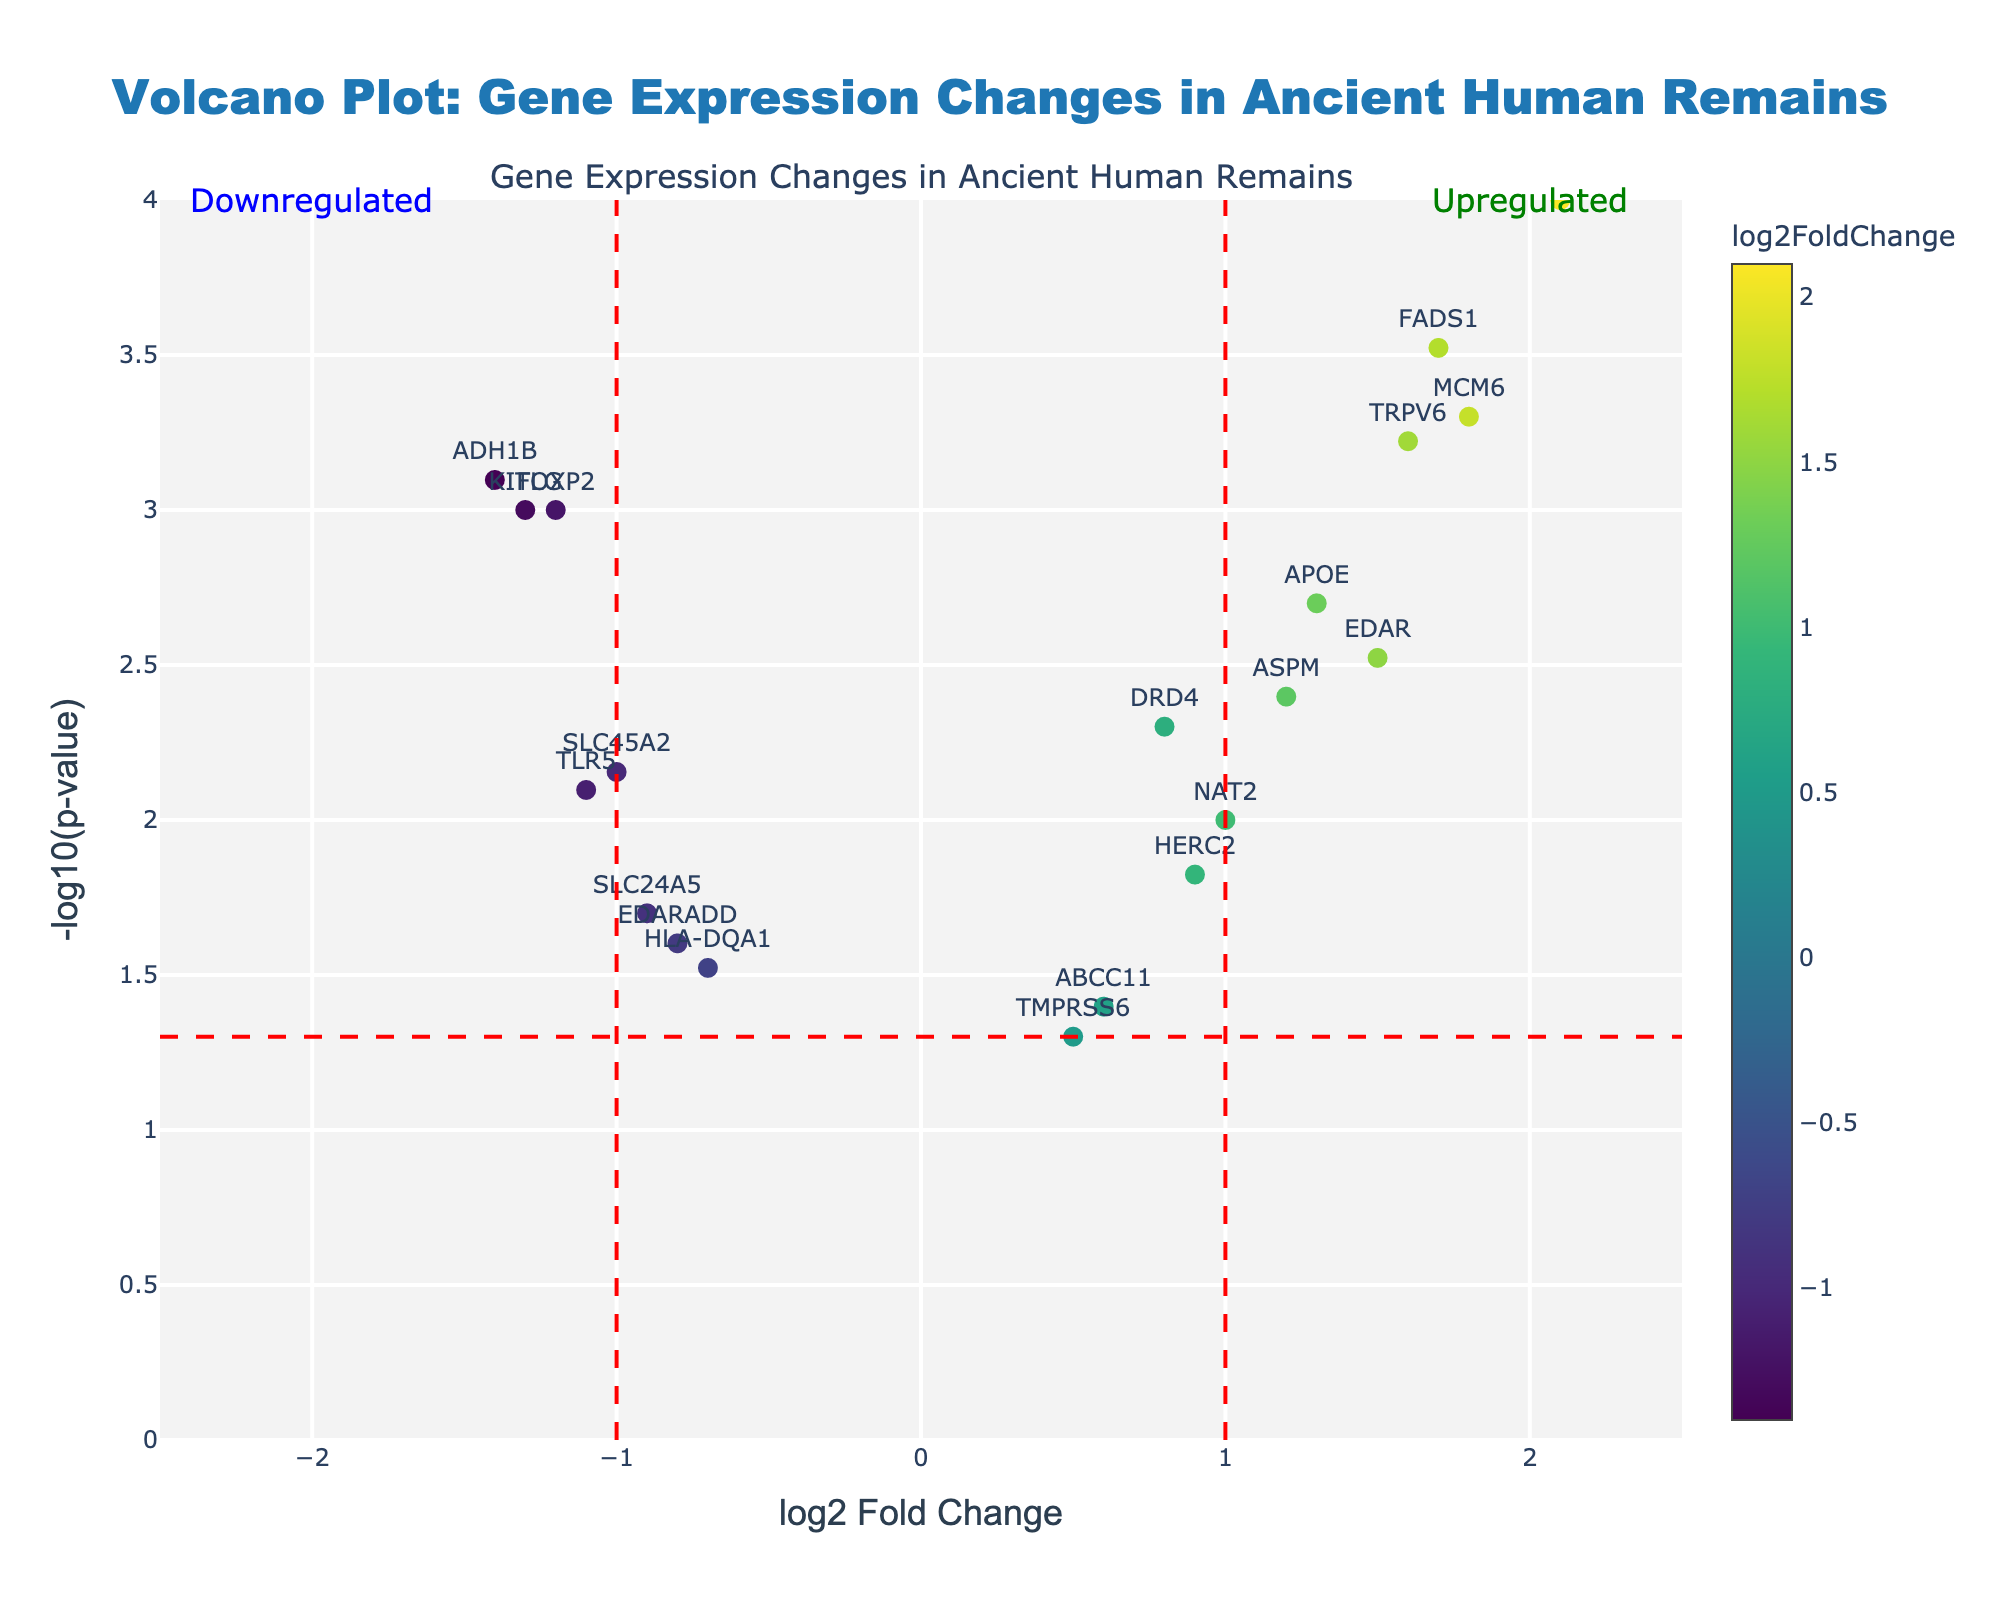How many genes are upregulated? Upregulated genes have a positive log2 Fold Change. In the plot, positive log2 Fold Change values include DRD4, LCT, EDAR, ABCC11, MCM6, APOE, NAT2, TMPRSS6, FADS1, HERC2, ASPM, and TRPV6. There are 12 such genes.
Answer: 12 Which gene has the highest level of upregulation and what is its log2 Fold Change? The highest level of upregulation is identified by the maximum positive log2 Fold Change. According to the plot, LCT with a log2 Fold Change of 2.1 is the most upregulated gene.
Answer: LCT, 2.1 Which gene has the highest statistical significance, and what is its p-value? The gene with the highest statistical significance will have the smallest p-value and the highest -log10(p-value). According to the plot, LCT has the highest -log10(p-value), corresponding to the smallest p-value of 0.0001.
Answer: LCT, 0.0001 Which genes are downregulated and have a p-value below 0.01? Downregulated genes have a negative log2 Fold Change, and those with -log10(p-value) > 2 (since -log10(0.01) = 2) will satisfy the p-value condition. These include FOXP2, TLR5, ADH1B, SLC45A2, and KITLG.
Answer: FOXP2, TLR5, ADH1B, SLC45A2, KITLG Which gene is closest to the threshold line of log2 Fold Change = 1? The threshold line of log2 Fold Change =1 is crossed by gene ASPM which has a log2 Fold Change of 1.2, and NAT2 with log2 Fold Change of 1.0. However, ASPM is closer to 1.
Answer: ASPM What is the range of log2 Fold Change values displayed in the plot? The log2 Fold Change ranges from the lowest downregulated value to the highest upregulated value. The smallest value is -1.4 (ADH1B), and the highest is 2.1 (LCT), giving a range of -1.4 to 2.1.
Answer: -1.4 to 2.1 How many genes have a log2 Fold Change between -1 and 1? Genes within this range include DRD4 (0.8), SLC24A5 (-0.9), ABCC11 (0.6), TLR5 (-1.1), HLA-DQA1 (-0.7), NAT2 (1.0), TMPRSS6 (0.5), SLC45A2 (-1.0), HERC2 (0.9), EDARADD (-0.8), and KITLG (-1.3).
Answer: 11 Which gene has the lowest statistical significance among upregulated genes? The lowest statistical significance among upregulated genes can be identified by the smallest -log10(p-value). TMPRSS6 has the highest p-value of 0.05 among upregulated genes.
Answer: TMPRSS6 